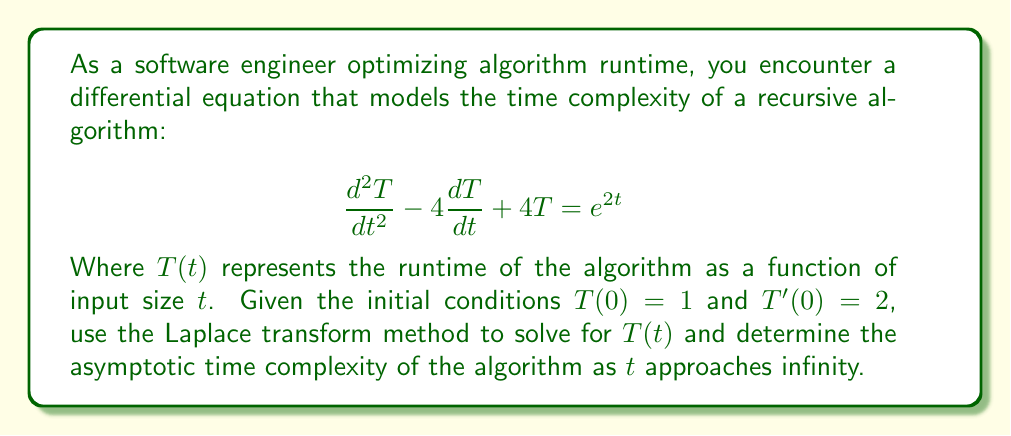Can you solve this math problem? 1) First, let's take the Laplace transform of both sides of the equation:
   $$\mathcal{L}\{T''(t) - 4T'(t) + 4T(t)\} = \mathcal{L}\{e^{2t}\}$$

2) Using Laplace transform properties:
   $$(s^2T(s) - sT(0) - T'(0)) - 4(sT(s) - T(0)) + 4T(s) = \frac{1}{s-2}$$

3) Substituting the initial conditions $T(0) = 1$ and $T'(0) = 2$:
   $$(s^2T(s) - s - 2) - 4(sT(s) - 1) + 4T(s) = \frac{1}{s-2}$$

4) Simplify:
   $$s^2T(s) - 4sT(s) + 4T(s) - s - 2 + 4 = \frac{1}{s-2}$$
   $$(s^2 - 4s + 4)T(s) = \frac{1}{s-2} + s - 2$$

5) Factor the left side:
   $$(s - 2)^2T(s) = \frac{1}{s-2} + s - 2$$

6) Solve for $T(s)$:
   $$T(s) = \frac{1}{(s-2)^3} + \frac{1}{s-2}$$

7) Take the inverse Laplace transform:
   $$T(t) = \mathcal{L}^{-1}\{\frac{1}{(s-2)^3} + \frac{1}{s-2}\}$$
   $$T(t) = \frac{1}{2}t^2e^{2t} + e^{2t}$$

8) To determine the asymptotic time complexity, we look at the behavior as $t$ approaches infinity:
   $$\lim_{t \to \infty} T(t) = \lim_{t \to \infty} (\frac{1}{2}t^2e^{2t} + e^{2t}) = \infty$$

   The dominant term is $\frac{1}{2}t^2e^{2t}$, which grows faster than any polynomial function.
Answer: $T(t) = \frac{1}{2}t^2e^{2t} + e^{2t}$; Asymptotic complexity: $O(t^2e^{2t})$ 